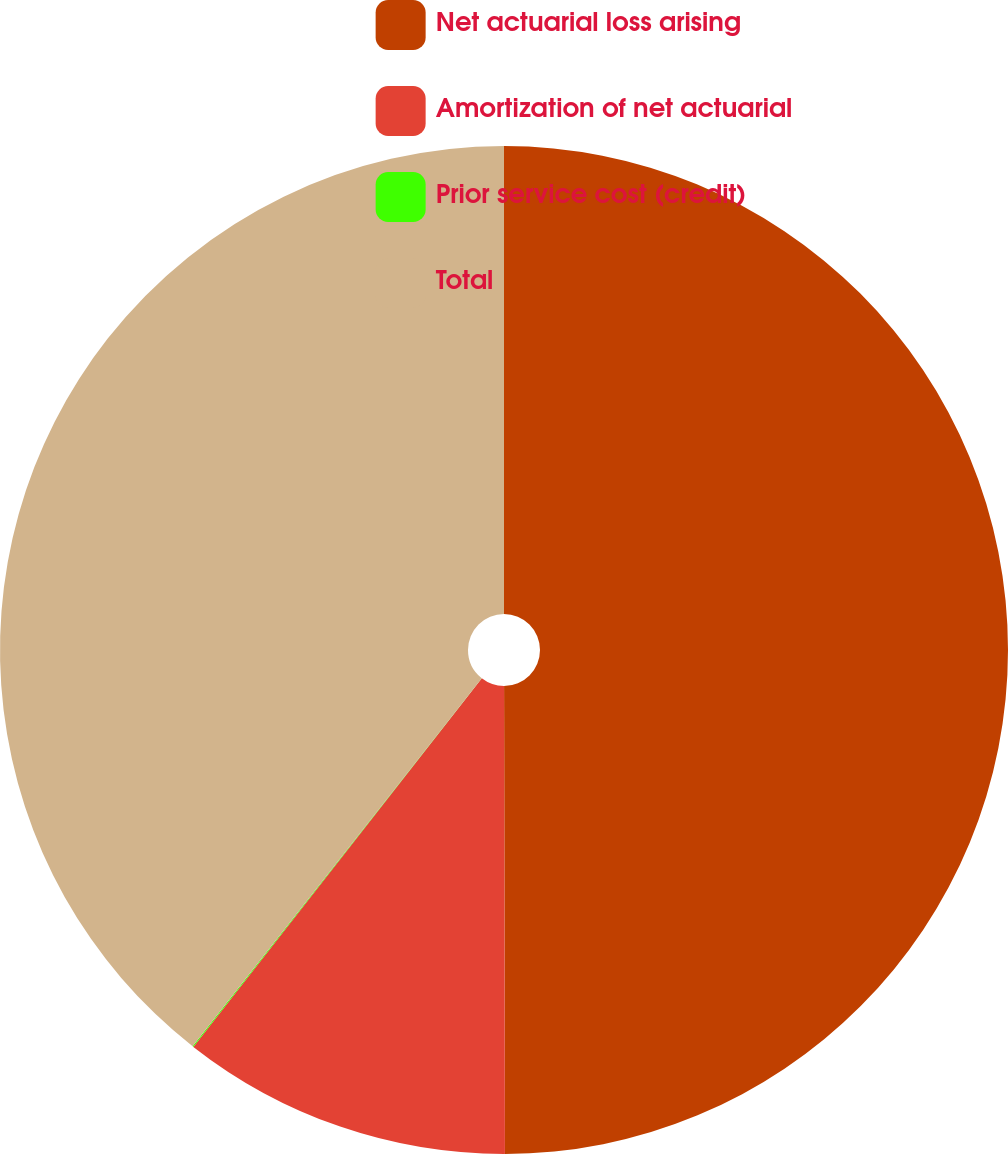<chart> <loc_0><loc_0><loc_500><loc_500><pie_chart><fcel>Net actuarial loss arising<fcel>Amortization of net actuarial<fcel>Prior service cost (credit)<fcel>Total<nl><fcel>49.97%<fcel>10.6%<fcel>0.03%<fcel>39.4%<nl></chart> 